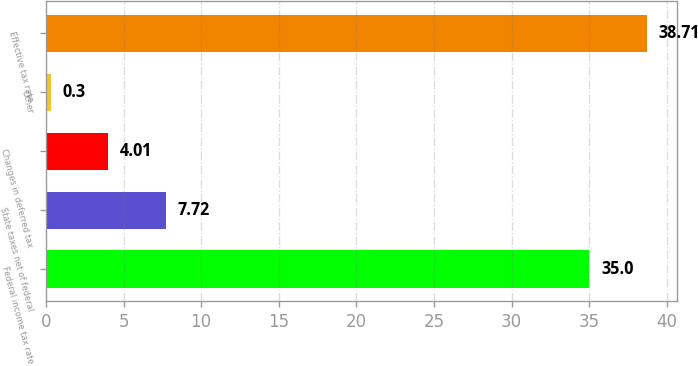Convert chart to OTSL. <chart><loc_0><loc_0><loc_500><loc_500><bar_chart><fcel>Federal income tax rate<fcel>State taxes net of federal<fcel>Changes in deferred tax<fcel>Other<fcel>Effective tax rate<nl><fcel>35<fcel>7.72<fcel>4.01<fcel>0.3<fcel>38.71<nl></chart> 